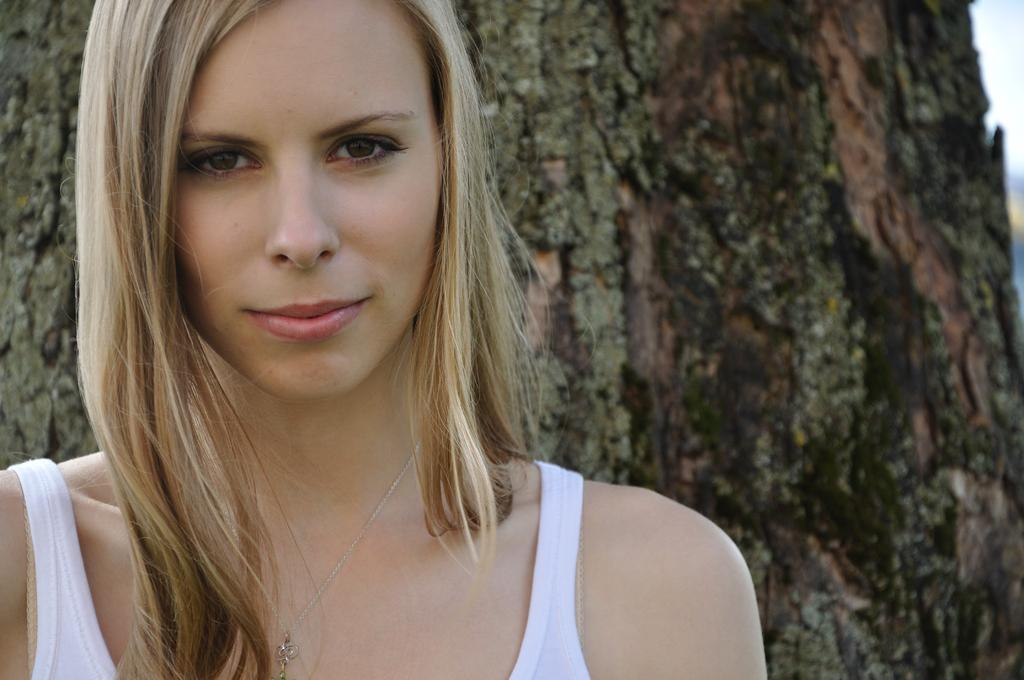Where was the image taken? The image was taken outdoors. What can be seen in the background of the image? There is a tree in the background of the image. Who is present in the image? There is a woman on the left side of the image. What is the woman's facial expression? The woman has a smiling face. What type of furniture can be seen in the image? There is no furniture present in the image. What drink is the woman holding in the image? The woman is not holding any drink in the image. 